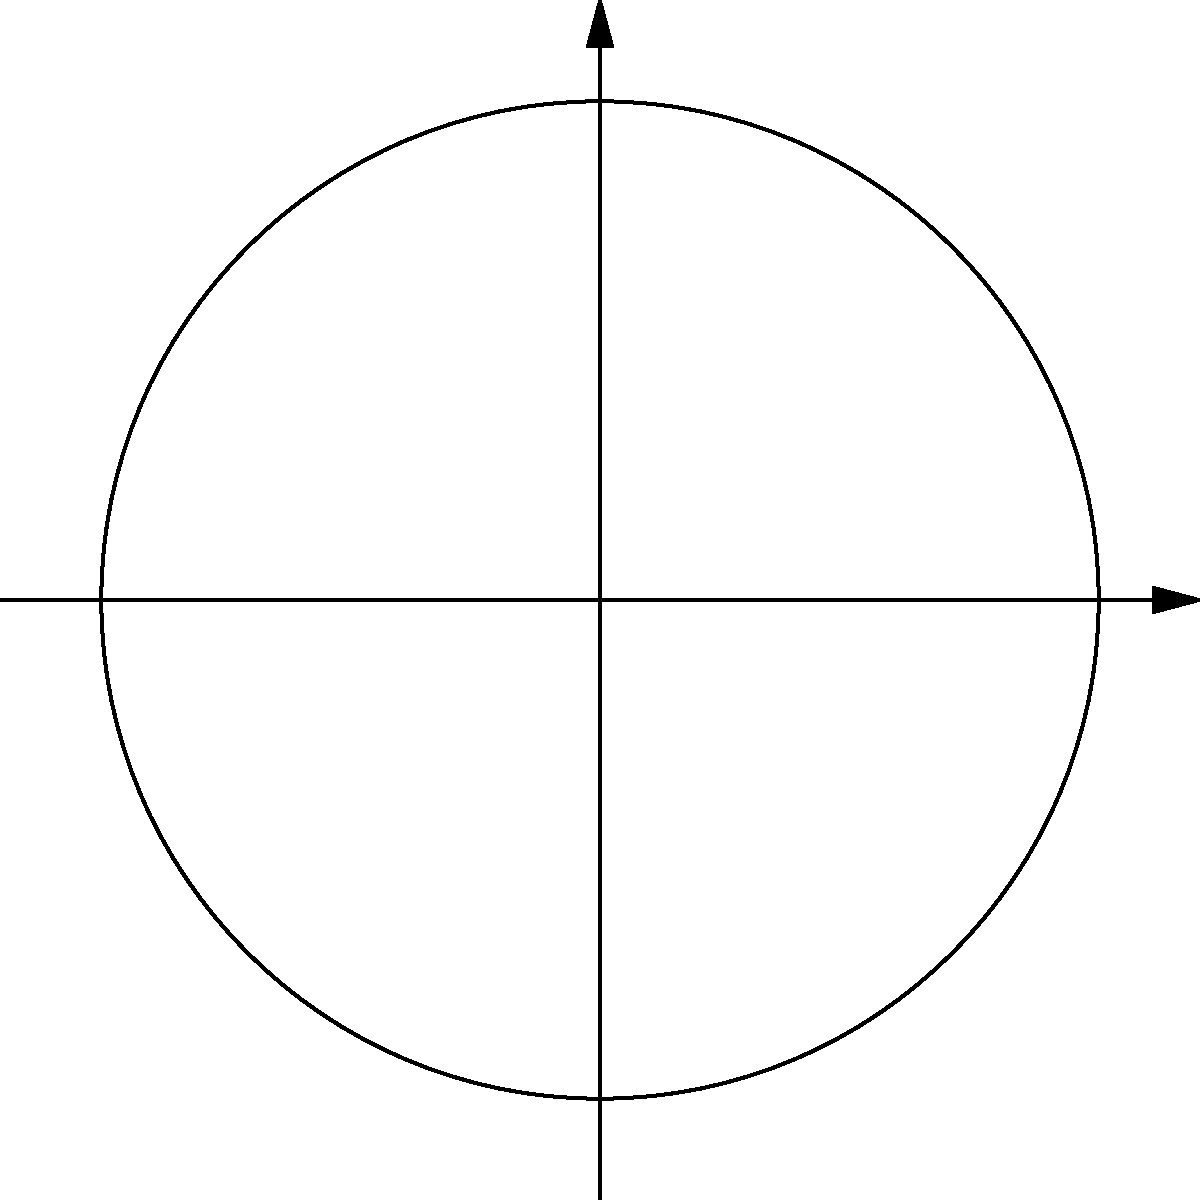An ancient Mayan structure is discovered during an archaeological expedition. Using polar coordinates, where North is 0° and angles increase counterclockwise, at what angle (to the nearest degree) does the structure align with respect to the cardinal directions if it points towards the rising sun in the East-Southeast direction? To solve this problem, we need to follow these steps:

1. Understand the polar coordinate system:
   - North is at 0°
   - East is at 90°
   - South is at 180°
   - West is at 270°

2. Identify the direction:
   - The structure points towards East-Southeast
   - East-Southeast is between East (90°) and Southeast (135°)

3. Estimate the angle:
   - The angle should be between 90° and 135°
   - East-Southeast is typically considered to be around 112.5° (halfway between East and Southeast)

4. Adjust for the question's coordinate system:
   - The question states that angles increase counterclockwise
   - In this system, we need to subtract our angle from 360°

5. Calculate the final angle:
   $$360° - 112.5° = 247.5°$$

6. Round to the nearest degree:
   $$247.5° ≈ 248°$$

Therefore, the ancient Mayan structure aligns at approximately 248° in the given polar coordinate system.
Answer: 248° 